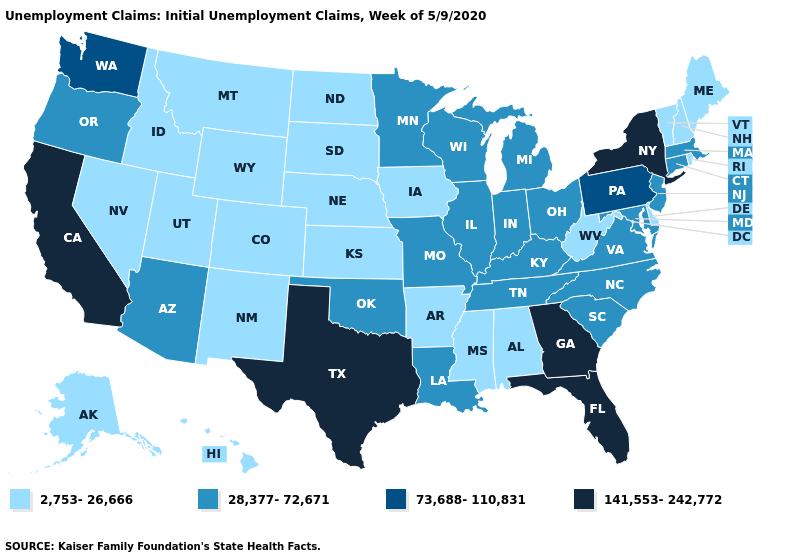What is the highest value in states that border Montana?
Answer briefly. 2,753-26,666. What is the lowest value in the South?
Concise answer only. 2,753-26,666. Among the states that border North Dakota , does Montana have the highest value?
Be succinct. No. Name the states that have a value in the range 2,753-26,666?
Write a very short answer. Alabama, Alaska, Arkansas, Colorado, Delaware, Hawaii, Idaho, Iowa, Kansas, Maine, Mississippi, Montana, Nebraska, Nevada, New Hampshire, New Mexico, North Dakota, Rhode Island, South Dakota, Utah, Vermont, West Virginia, Wyoming. Which states hav the highest value in the MidWest?
Answer briefly. Illinois, Indiana, Michigan, Minnesota, Missouri, Ohio, Wisconsin. Among the states that border Arkansas , which have the highest value?
Quick response, please. Texas. What is the value of Nevada?
Concise answer only. 2,753-26,666. Which states hav the highest value in the Northeast?
Concise answer only. New York. What is the lowest value in states that border Ohio?
Concise answer only. 2,753-26,666. Among the states that border Vermont , does New Hampshire have the highest value?
Quick response, please. No. Does New Hampshire have the lowest value in the Northeast?
Answer briefly. Yes. Is the legend a continuous bar?
Write a very short answer. No. Which states have the highest value in the USA?
Quick response, please. California, Florida, Georgia, New York, Texas. Name the states that have a value in the range 141,553-242,772?
Give a very brief answer. California, Florida, Georgia, New York, Texas. Which states have the lowest value in the USA?
Keep it brief. Alabama, Alaska, Arkansas, Colorado, Delaware, Hawaii, Idaho, Iowa, Kansas, Maine, Mississippi, Montana, Nebraska, Nevada, New Hampshire, New Mexico, North Dakota, Rhode Island, South Dakota, Utah, Vermont, West Virginia, Wyoming. 